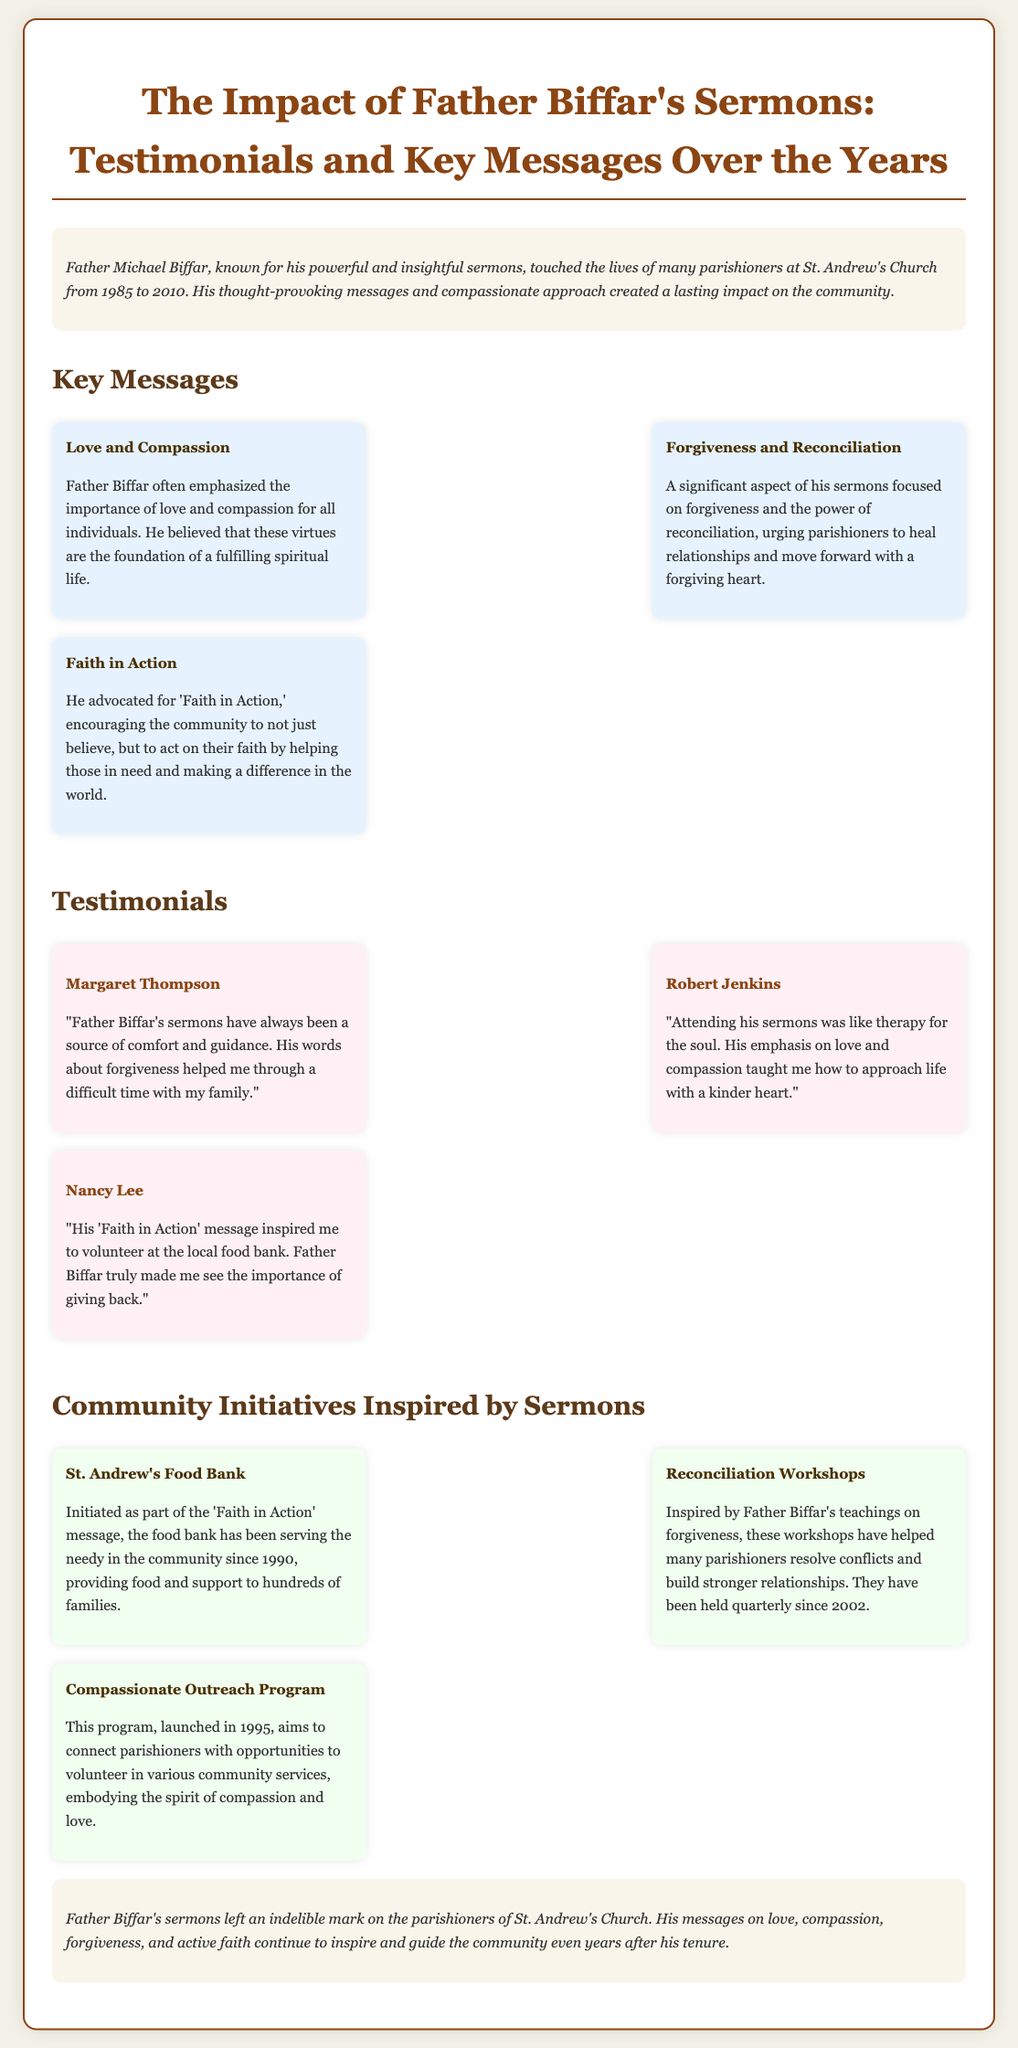what years did Father Biffar serve at St. Andrew's Church? The document states that Father Biffar served from 1985 to 2010.
Answer: 1985 to 2010 what is one key message emphasized in Father Biffar's sermons? The document lists key messages, including "Love and Compassion".
Answer: Love and Compassion who is one of the individuals who provided a testimonial about Father Biffar's sermons? The document includes testimonials from individuals, one being "Margaret Thompson".
Answer: Margaret Thompson when did the St. Andrew's Food Bank initiate? According to the document, the food bank started in 1990.
Answer: 1990 what is the primary focus of the "Reconciliation Workshops"? The document mentions that these workshops help resolve conflicts and build stronger relationships.
Answer: Resolve conflicts how many different community initiatives inspired by Father Biffar's sermons are mentioned? The document lists three initiatives under the section "Community Initiatives Inspired by Sermons".
Answer: Three what specific aspect of life does Father Biffar believe is the foundation of a fulfilling spiritual life? The document states that Father Biffar believed in the importance of "love and compassion".
Answer: Love and compassion what year did the "Compassionate Outreach Program" launch? The document notes that this program was launched in 1995.
Answer: 1995 